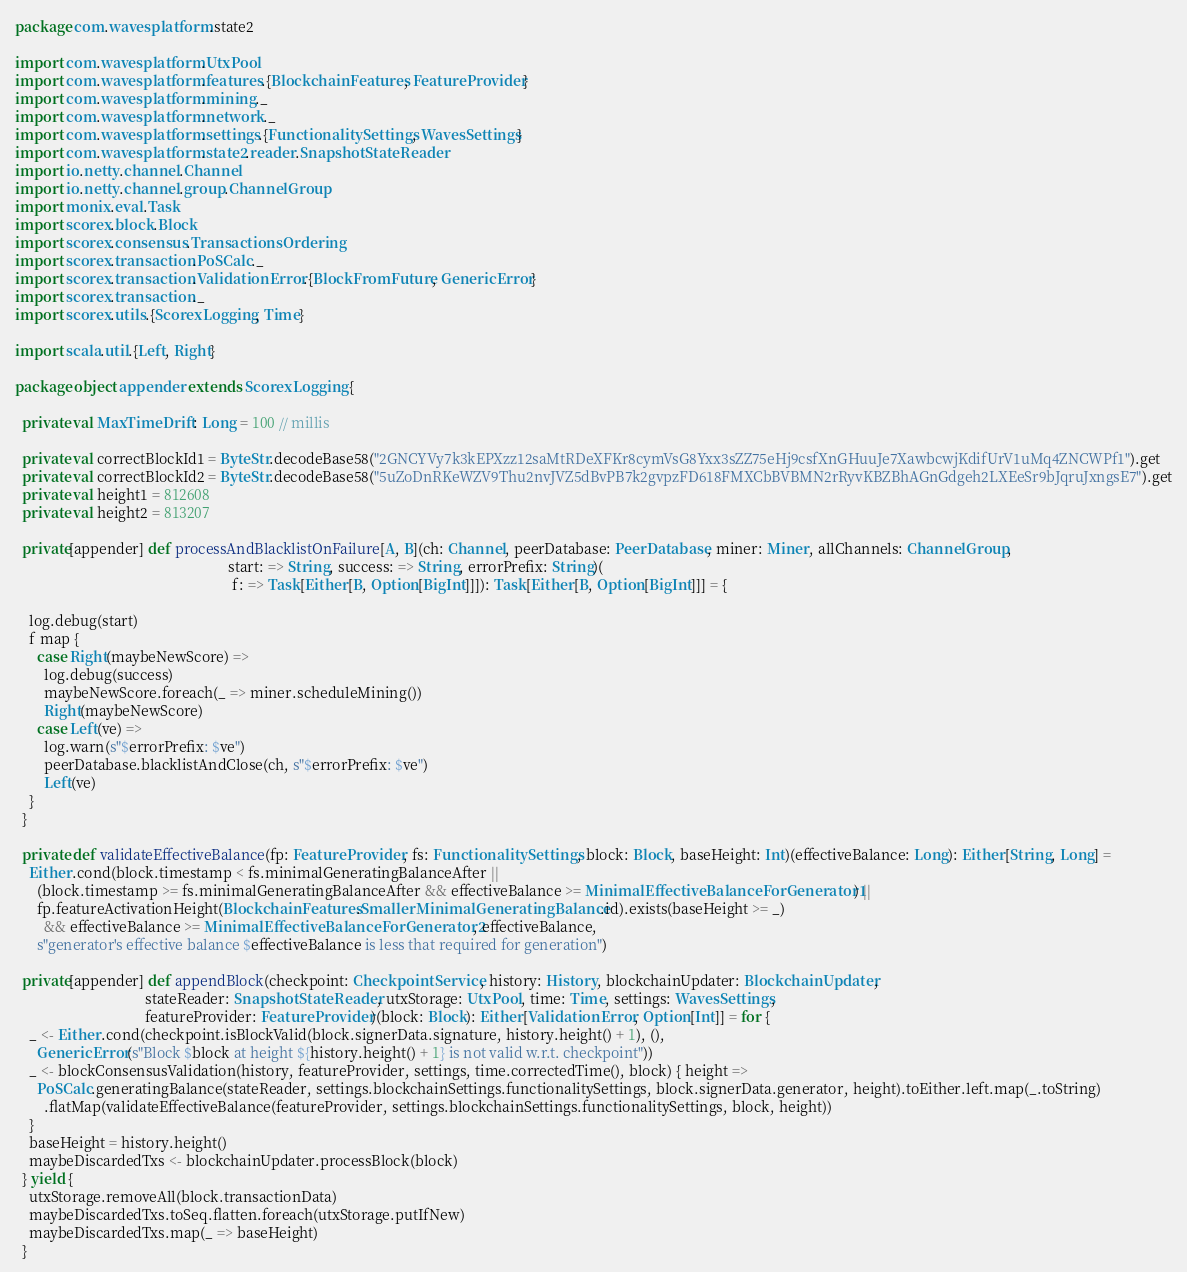<code> <loc_0><loc_0><loc_500><loc_500><_Scala_>package com.wavesplatform.state2

import com.wavesplatform.UtxPool
import com.wavesplatform.features.{BlockchainFeatures, FeatureProvider}
import com.wavesplatform.mining._
import com.wavesplatform.network._
import com.wavesplatform.settings.{FunctionalitySettings, WavesSettings}
import com.wavesplatform.state2.reader.SnapshotStateReader
import io.netty.channel.Channel
import io.netty.channel.group.ChannelGroup
import monix.eval.Task
import scorex.block.Block
import scorex.consensus.TransactionsOrdering
import scorex.transaction.PoSCalc._
import scorex.transaction.ValidationError.{BlockFromFuture, GenericError}
import scorex.transaction._
import scorex.utils.{ScorexLogging, Time}

import scala.util.{Left, Right}

package object appender extends ScorexLogging {

  private val MaxTimeDrift: Long = 100 // millis

  private val correctBlockId1 = ByteStr.decodeBase58("2GNCYVy7k3kEPXzz12saMtRDeXFKr8cymVsG8Yxx3sZZ75eHj9csfXnGHuuJe7XawbcwjKdifUrV1uMq4ZNCWPf1").get
  private val correctBlockId2 = ByteStr.decodeBase58("5uZoDnRKeWZV9Thu2nvJVZ5dBvPB7k2gvpzFD618FMXCbBVBMN2rRyvKBZBhAGnGdgeh2LXEeSr9bJqruJxngsE7").get
  private val height1 = 812608
  private val height2 = 813207

  private[appender] def processAndBlacklistOnFailure[A, B](ch: Channel, peerDatabase: PeerDatabase, miner: Miner, allChannels: ChannelGroup,
                                                           start: => String, success: => String, errorPrefix: String)(
                                                            f: => Task[Either[B, Option[BigInt]]]): Task[Either[B, Option[BigInt]]] = {

    log.debug(start)
    f map {
      case Right(maybeNewScore) =>
        log.debug(success)
        maybeNewScore.foreach(_ => miner.scheduleMining())
        Right(maybeNewScore)
      case Left(ve) =>
        log.warn(s"$errorPrefix: $ve")
        peerDatabase.blacklistAndClose(ch, s"$errorPrefix: $ve")
        Left(ve)
    }
  }

  private def validateEffectiveBalance(fp: FeatureProvider, fs: FunctionalitySettings, block: Block, baseHeight: Int)(effectiveBalance: Long): Either[String, Long] =
    Either.cond(block.timestamp < fs.minimalGeneratingBalanceAfter ||
      (block.timestamp >= fs.minimalGeneratingBalanceAfter && effectiveBalance >= MinimalEffectiveBalanceForGenerator1) ||
      fp.featureActivationHeight(BlockchainFeatures.SmallerMinimalGeneratingBalance.id).exists(baseHeight >= _)
        && effectiveBalance >= MinimalEffectiveBalanceForGenerator2, effectiveBalance,
      s"generator's effective balance $effectiveBalance is less that required for generation")

  private[appender] def appendBlock(checkpoint: CheckpointService, history: History, blockchainUpdater: BlockchainUpdater,
                                    stateReader: SnapshotStateReader, utxStorage: UtxPool, time: Time, settings: WavesSettings,
                                    featureProvider: FeatureProvider)(block: Block): Either[ValidationError, Option[Int]] = for {
    _ <- Either.cond(checkpoint.isBlockValid(block.signerData.signature, history.height() + 1), (),
      GenericError(s"Block $block at height ${history.height() + 1} is not valid w.r.t. checkpoint"))
    _ <- blockConsensusValidation(history, featureProvider, settings, time.correctedTime(), block) { height =>
      PoSCalc.generatingBalance(stateReader, settings.blockchainSettings.functionalitySettings, block.signerData.generator, height).toEither.left.map(_.toString)
        .flatMap(validateEffectiveBalance(featureProvider, settings.blockchainSettings.functionalitySettings, block, height))
    }
    baseHeight = history.height()
    maybeDiscardedTxs <- blockchainUpdater.processBlock(block)
  } yield {
    utxStorage.removeAll(block.transactionData)
    maybeDiscardedTxs.toSeq.flatten.foreach(utxStorage.putIfNew)
    maybeDiscardedTxs.map(_ => baseHeight)
  }
</code> 